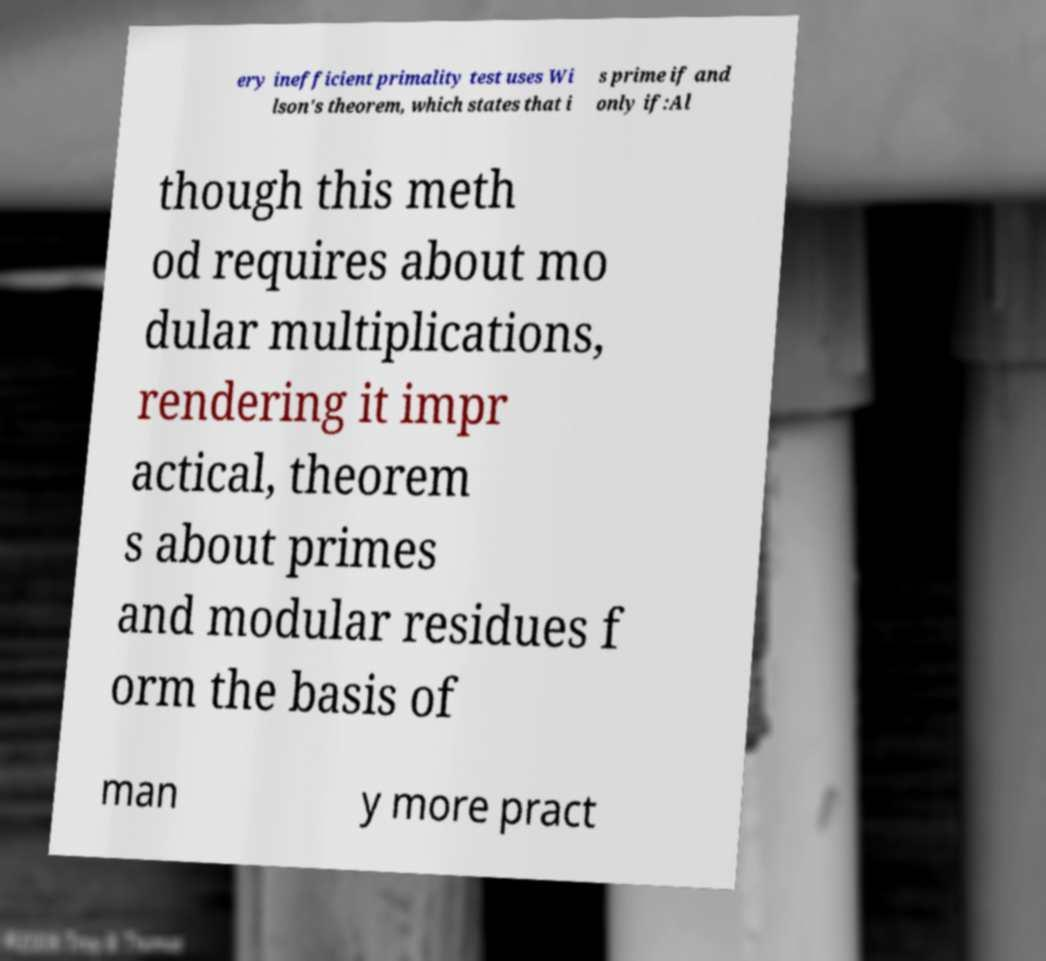For documentation purposes, I need the text within this image transcribed. Could you provide that? ery inefficient primality test uses Wi lson's theorem, which states that i s prime if and only if:Al though this meth od requires about mo dular multiplications, rendering it impr actical, theorem s about primes and modular residues f orm the basis of man y more pract 